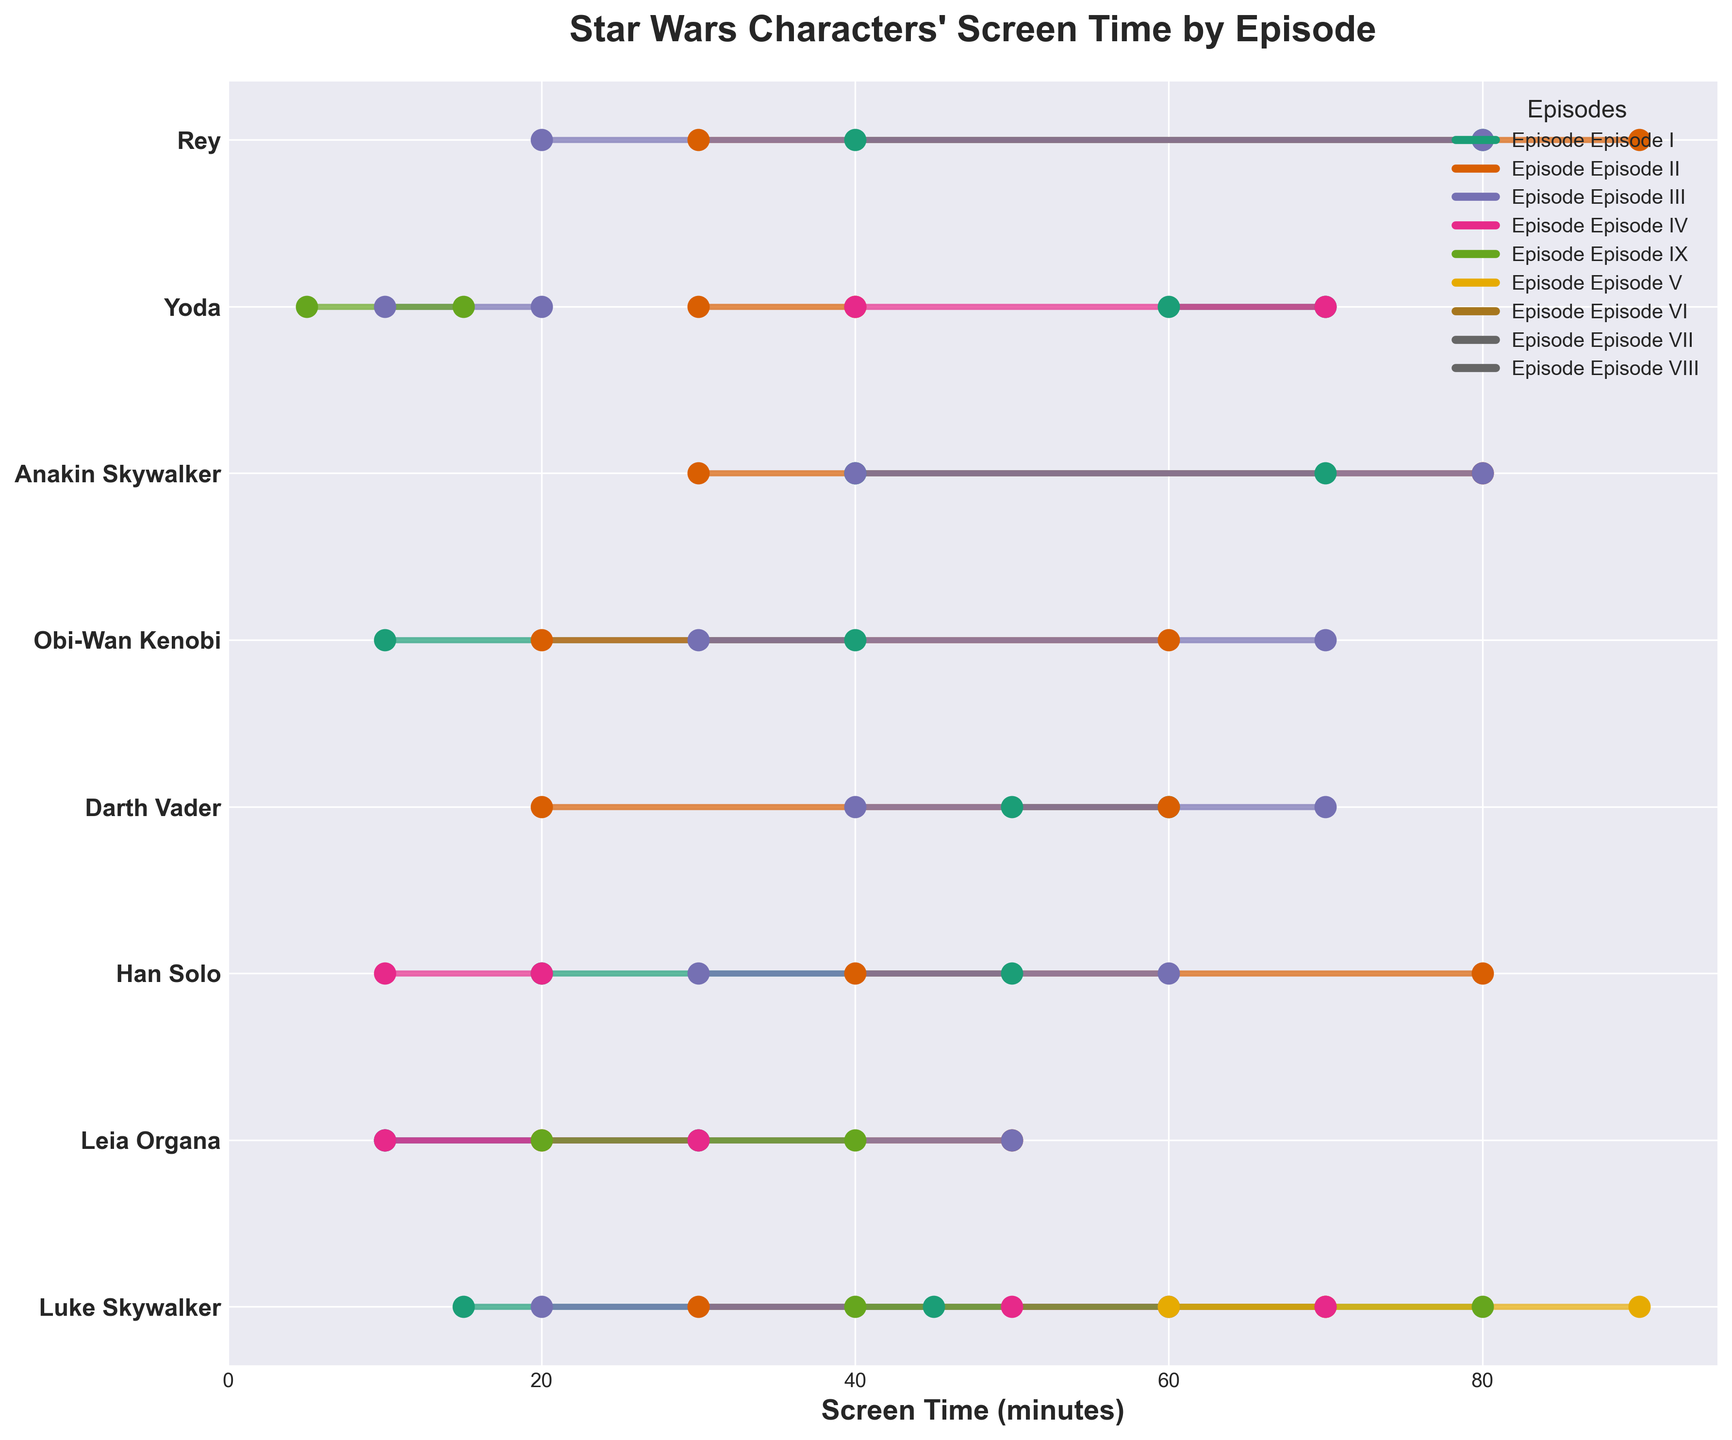What is the title of the plot? The title is located at the top of the plot and describes what the plot is about.
Answer: Star Wars Characters' Screen Time by Episode Which character has the longest screen time range in Episode VII? Look for the longest horizontal line in Episode VII for each character.
Answer: Rey How many episodes did Yoda appear in? Count the number of horizontal lines associated with Yoda.
Answer: 5 Which character appears in Episode IX and has the smallest screen time range? Compare the lengths of the horizontal lines in Episode IX for each character.
Answer: Rey How does Luke Skywalker's screen time in Episode VIII compare to his screen time in Episode VI? Compare the start and end points of Luke Skywalker's screen times for the two episodes. In Episode VIII, he appears from minute 40 to 80, while in Episode VI, he appears from minute 20 to 60.
Answer: Longer in Episode VIII Which characters are present in all three episodes of the original trilogy (Episodes IV, V, and VI)? Identify characters with screen time ranges in Episodes IV, V, and VI.
Answer: Luke Skywalker, Leia Organa, Han Solo, Darth Vader, Yoda What is the average start time of Obi-Wan Kenobi's screen time across all prequel episodes (Episodes I, II, and III)? Add the start times of Obi-Wan Kenobi in Episodes I (10 min), II (20 min), and III (30 min), and divide by 3.
Answer: 20 min In which episode does Anakin Skywalker have the longest screen time range? Compare the lengths of the horizontal lines in each episode for Anakin Skywalker.
Answer: Episode II Compare the screen time ranges of Han Solo in Episodes IV and V. Which one is longer? Determine the difference between the start and end times for Han Solo in both episodes and compare the two.
Answer: Episode V Based on the plot, what trend can you observe about Luke Skywalker's screen time from Episode IV to Episode IX? Look at the sequential horizontal lines for Luke Skywalker from Episode IV to Episode IX and observe the changes in screen time range. Luke's screen time generally increases over the sequels.
Answer: Increases 